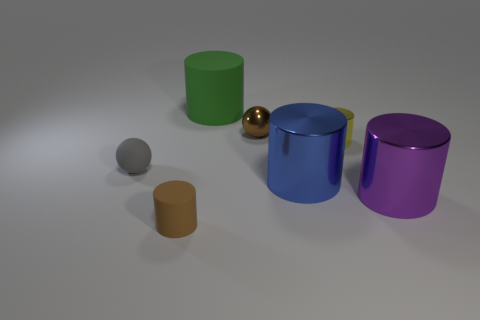Is there any other thing that has the same size as the yellow shiny cylinder?
Make the answer very short. Yes. The matte object on the left side of the small brown thing that is in front of the brown ball is what color?
Offer a very short reply. Gray. What is the color of the other shiny cylinder that is the same size as the purple metallic cylinder?
Offer a very short reply. Blue. Are there any other big objects that have the same shape as the gray rubber thing?
Your answer should be very brief. No. The yellow metal object has what shape?
Provide a succinct answer. Cylinder. Is the number of brown metal objects that are behind the big matte thing greater than the number of tiny yellow metal objects left of the tiny metal sphere?
Provide a short and direct response. No. What number of other things are the same size as the green matte cylinder?
Offer a very short reply. 2. The cylinder that is both on the left side of the yellow metallic cylinder and right of the tiny brown sphere is made of what material?
Keep it short and to the point. Metal. There is another small object that is the same shape as the brown metal object; what material is it?
Ensure brevity in your answer.  Rubber. How many small objects are left of the large metallic thing on the left side of the large thing to the right of the big blue metallic thing?
Offer a very short reply. 3. 